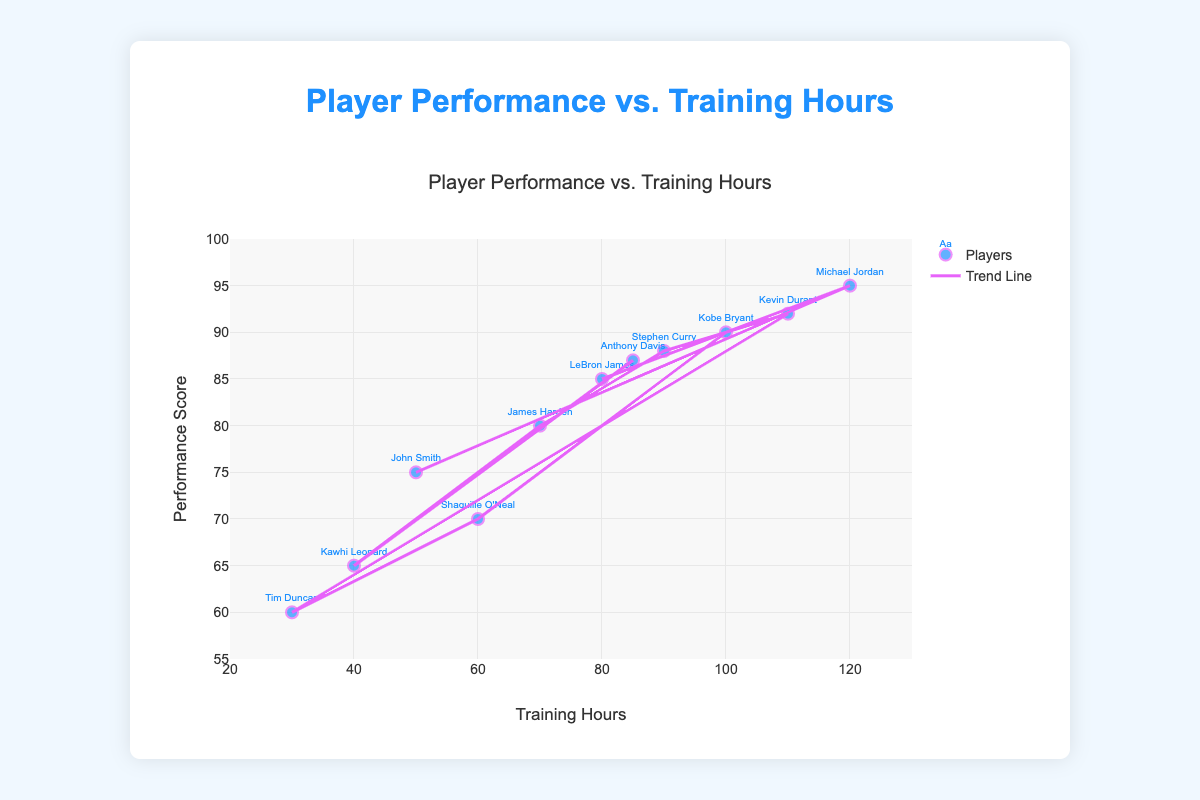What is the title of the scatter plot? The title of the scatter plot is located at the top of the figure and is labeled in larger, distinct font.
Answer: Player Performance vs. Training Hours How many players are included in the scatter plot? Each player corresponds to one data point, and the total number of data points equals the number of players. Counting them gives us 11 players.
Answer: 11 Which player has the highest performance score, and what is the score? Locate the data point with the highest value on the y-axis and match it to the corresponding label. This player is Michael Jordan with a performance score of 95.
Answer: Michael Jordan, 95 What is the general trend shown by the trend line in the scatter plot? The trend line indicates the overall direction of the data points. Here, it shows a positive relationship, meaning that as training hours increase, player performance tends to increase as well.
Answer: Positive relationship Which player has the least training hours, and how many hours did they train? Find the data point closest to the left on the x-axis and match it to the corresponding label. This player is Tim Duncan with 30 training hours.
Answer: Tim Duncan, 30 How does John Smith's performance score compare to the general trend? Locate John Smith's data point and compare the y-value (performance score) to where the trend line is at his x-value (training hours). John's performance score is significantly below the trend line, making him an underperformer relative to the trend.
Answer: Below the trend What's the range of training hours represented in the scatter plot? Identify the minimum and maximum values on the x-axis, 30 to 120. The range is the difference between these values, which is 120 - 30 = 90.
Answer: 90 How many players have a performance score higher than 85? Count the data points that lie above the y-axis value of 85. We see Michael Jordan (95), Kevin Durant (92), Stephen Curry (88), and Anthony Davis (87). Thus, there are 4 players.
Answer: 4 Which player underwent more training hours, Stephen Curry or LeBron James, and by how much? Compare the x-values of their data points. Stephen Curry trained for 90 hours, while LeBron James trained for 80 hours. The difference is 90 - 80 = 10 hours.
Answer: Stephen Curry, 10 hours What performance score corresponds to 100 training hours based on the trend line? Locate the point on the trend line that aligns with 100 training hours on the x-axis and check its corresponding y-value. This approximates the performance score quite close to 90.
Answer: Approximately 90 